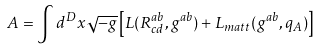Convert formula to latex. <formula><loc_0><loc_0><loc_500><loc_500>A = \int d ^ { D } x \sqrt { - g } \left [ L ( R ^ { a b } _ { c d } , g ^ { a b } ) + L _ { m a t t } ( g ^ { a b } , q _ { A } ) \right ]</formula> 